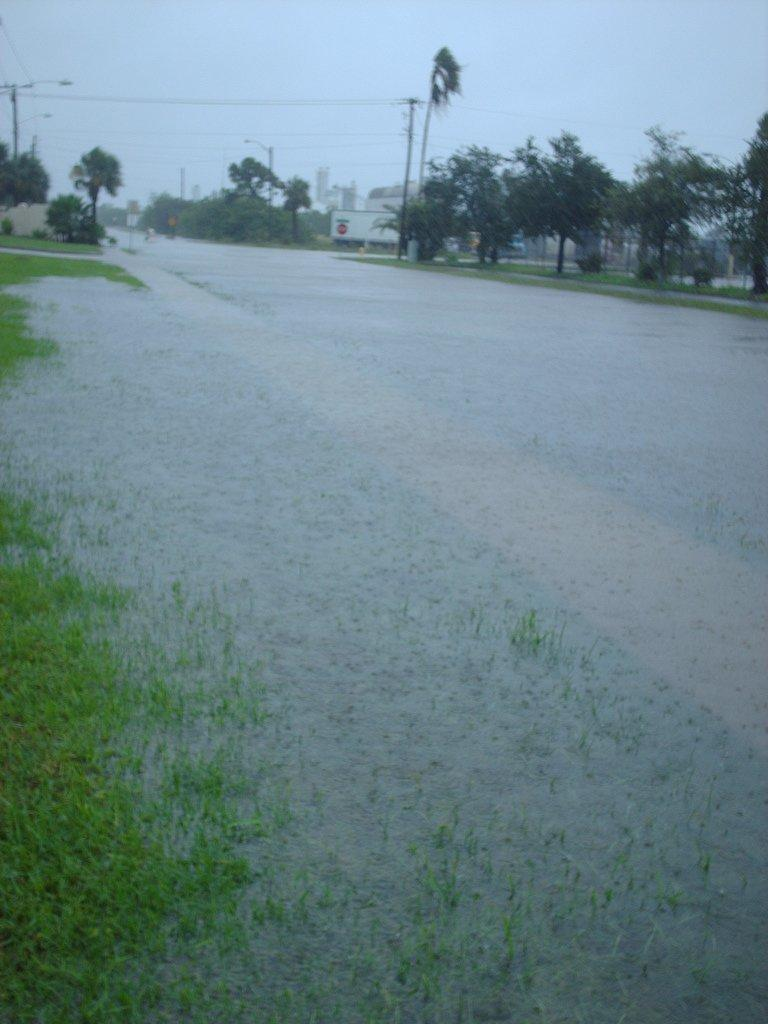What is at the bottom of the image? There is water and grass at the bottom of the image. What can be seen in the background of the image? There are trees, poles, and lights in the background of the image. What is visible at the top of the image? The sky is visible at the top of the image. Can you see a brain floating in the water at the bottom of the image? No, there is no brain visible in the water at the bottom of the image. Are there any matches present in the image? No, there are no matches present in the image. 